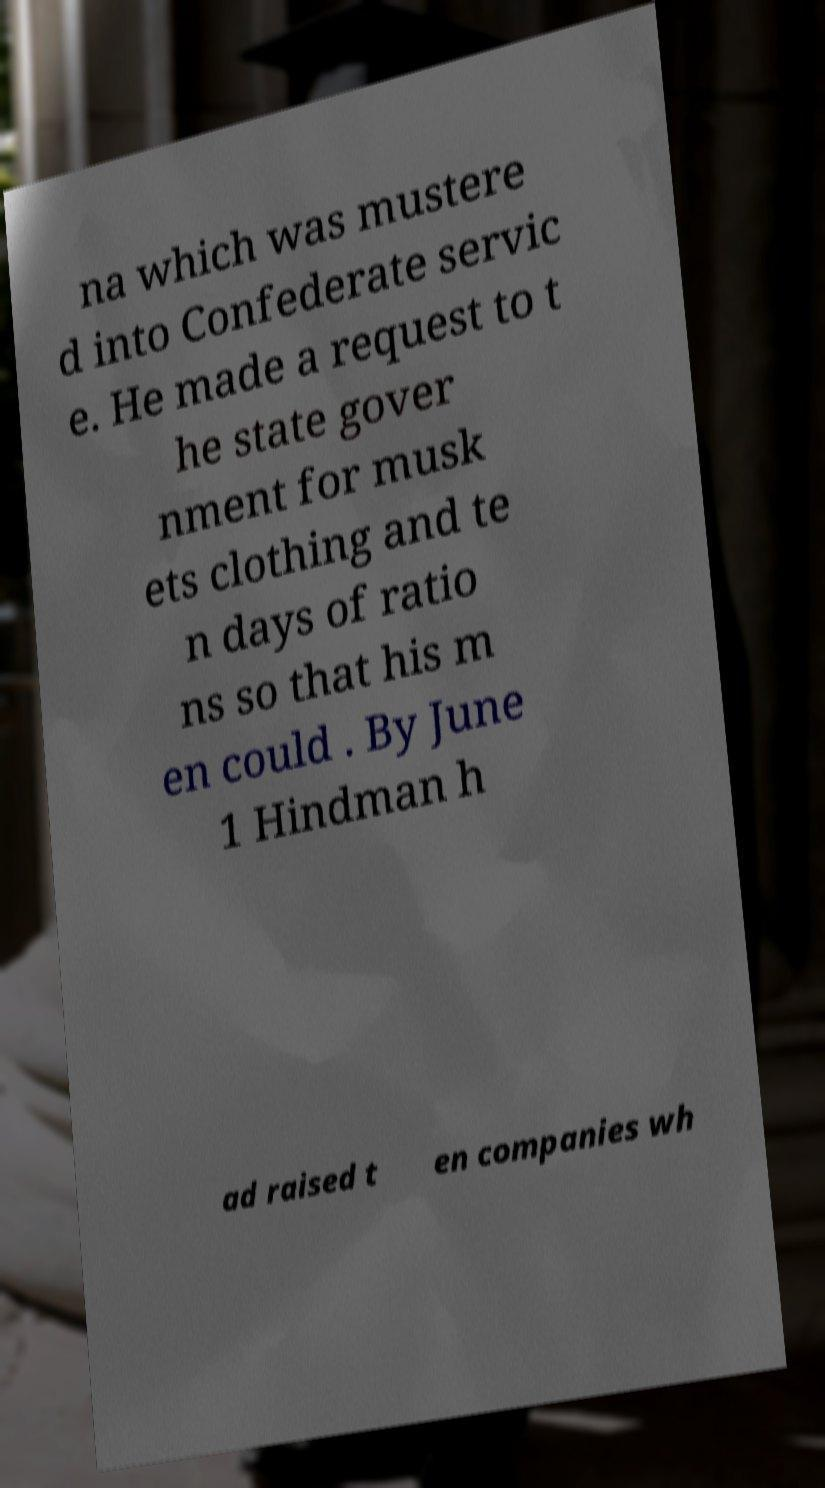Could you assist in decoding the text presented in this image and type it out clearly? na which was mustere d into Confederate servic e. He made a request to t he state gover nment for musk ets clothing and te n days of ratio ns so that his m en could . By June 1 Hindman h ad raised t en companies wh 